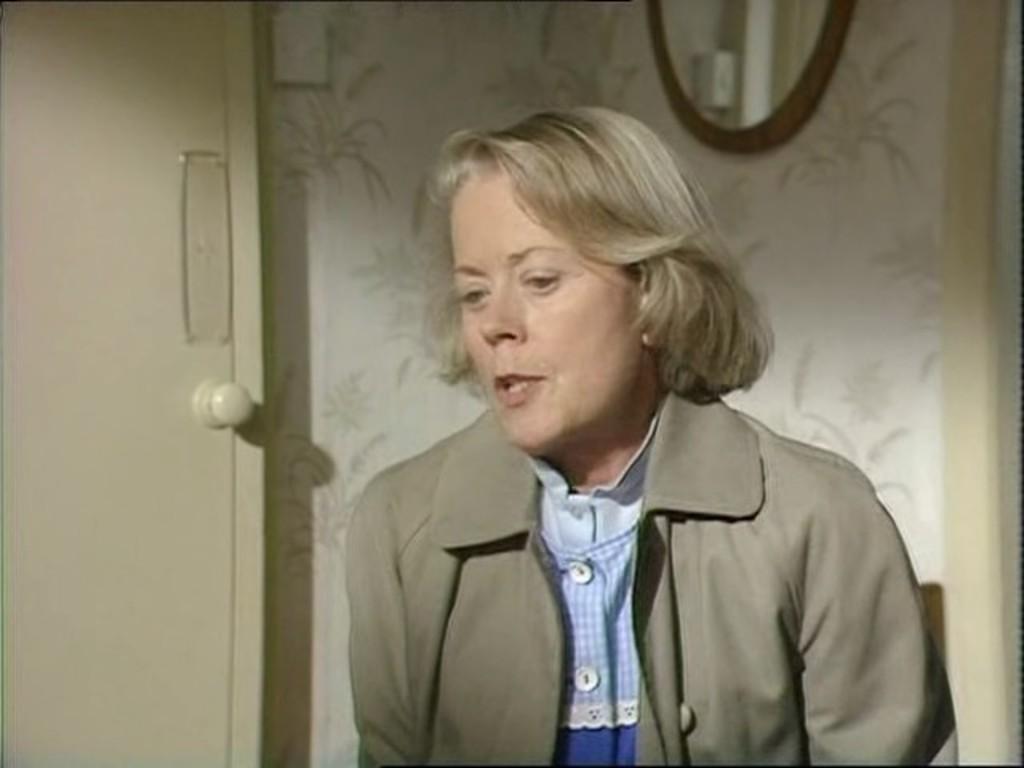How would you summarize this image in a sentence or two? This image consists of a woman. She is wearing a coat. There is a door on the left side. There is a mirror at the top. 